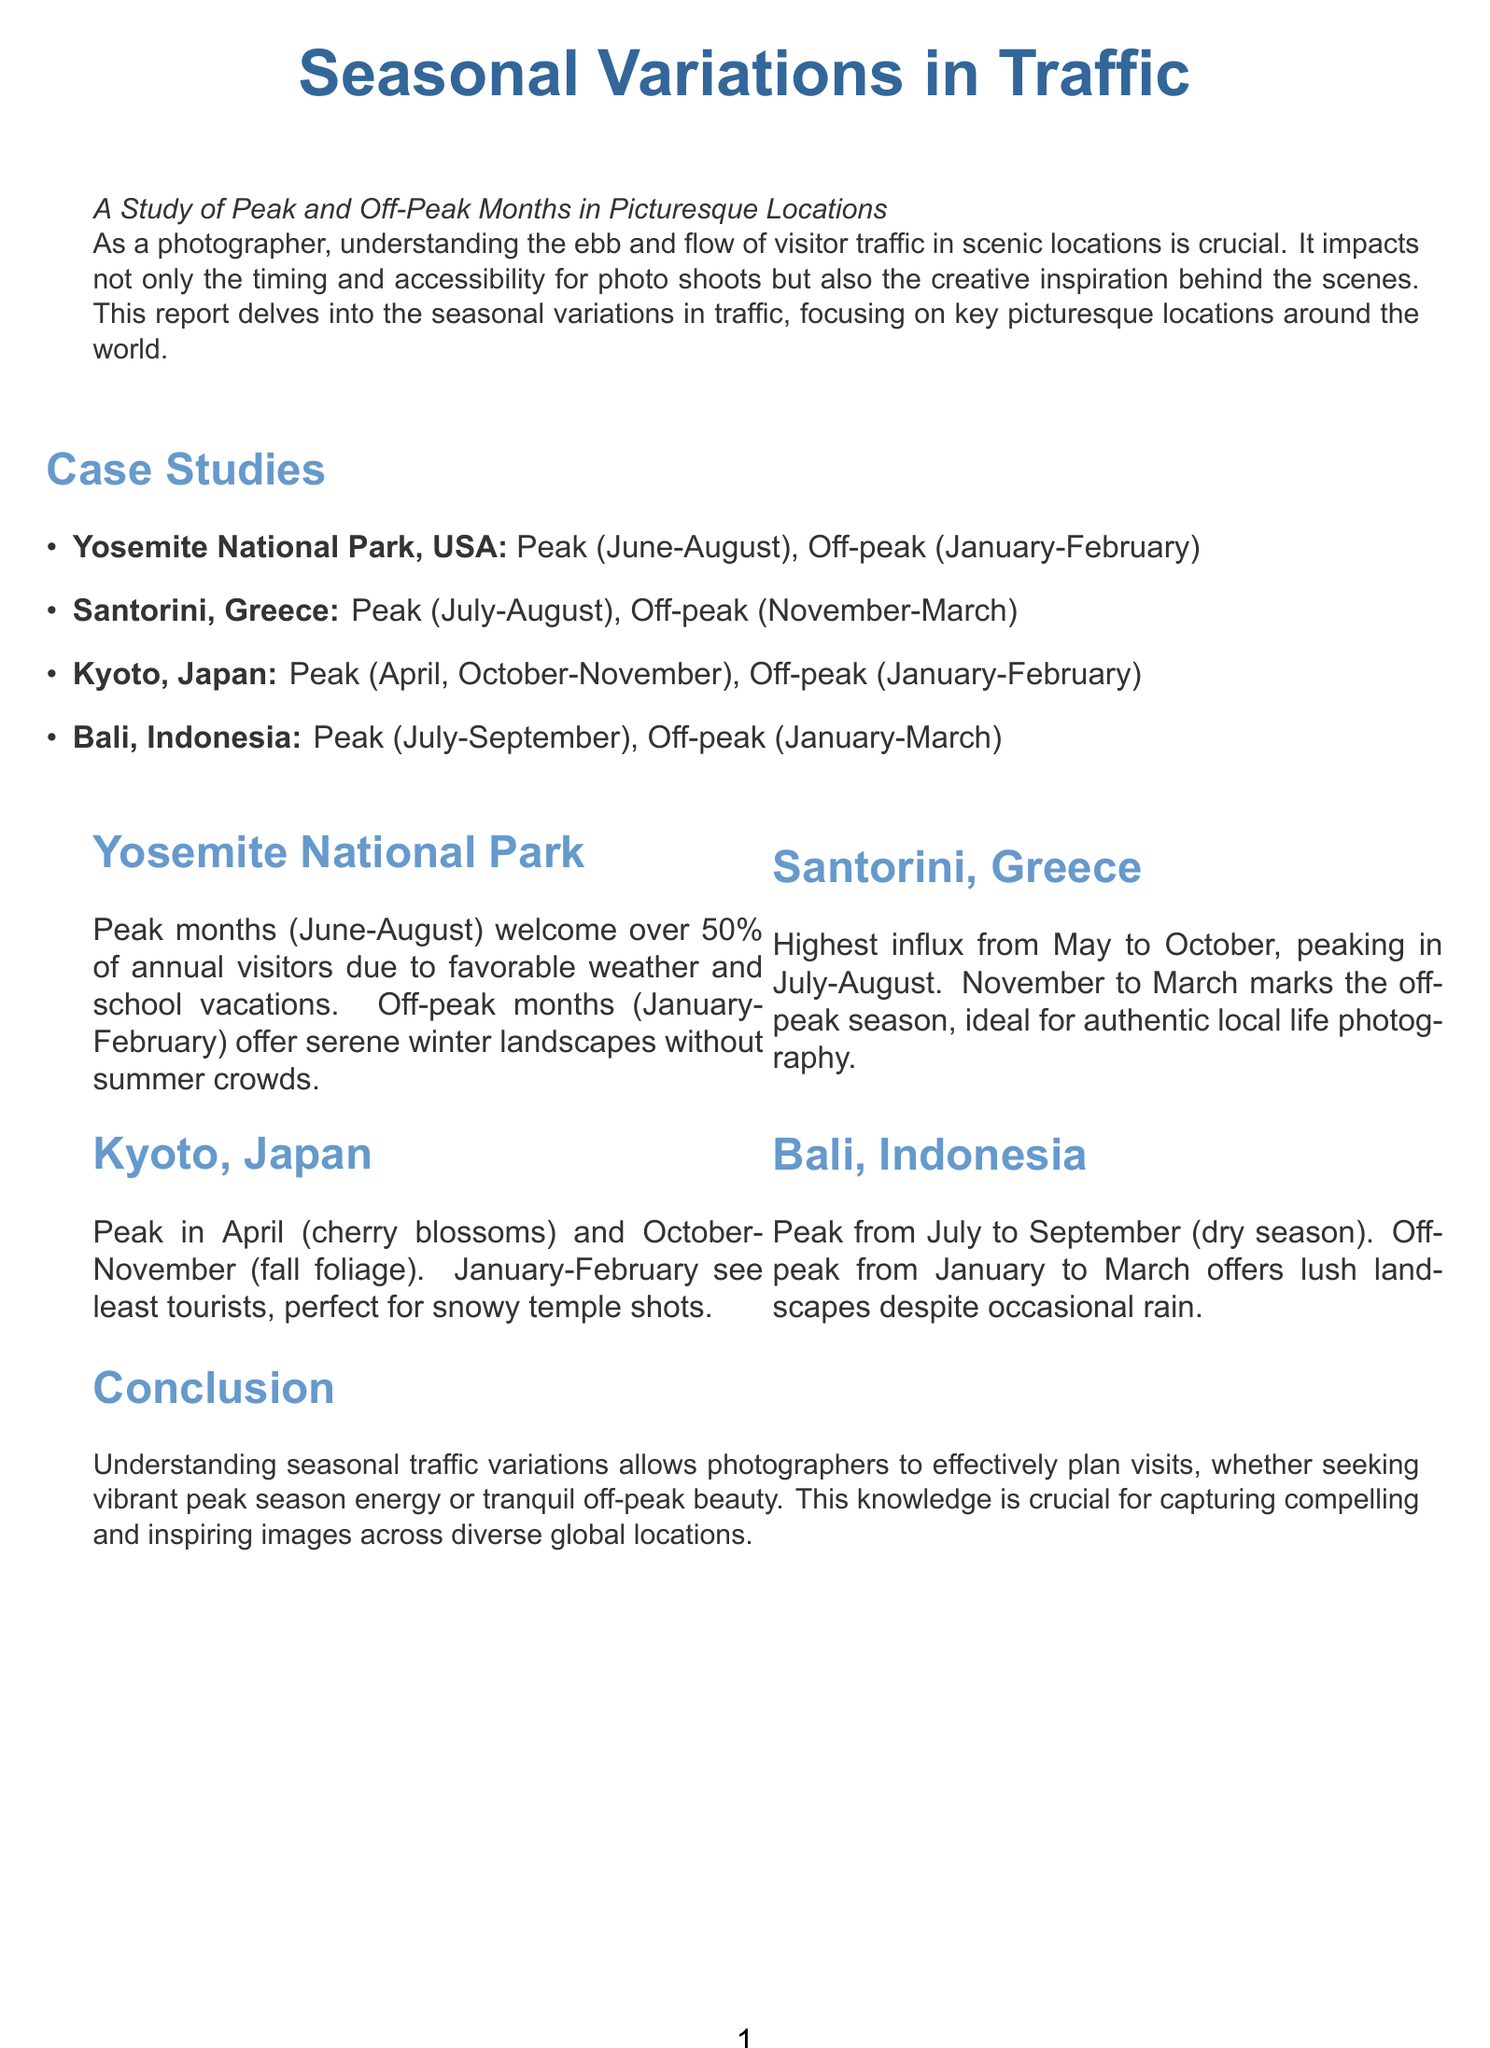What are the peak months for Yosemite National Park? The peak months are identified as June to August, based on the data presented in the case studies section of the report.
Answer: June-August What is the off-peak season for Santorini, Greece? The off-peak season for Santorini is specified as November to March, as noted in the case studies section.
Answer: November-March During which months does Kyoto, Japan, see the least tourists? The report indicates that the least tourists visit Kyoto during January and February.
Answer: January-February What is the peak season for Bali, Indonesia? The peak season for Bali is categorized as July to September in the case studies.
Answer: July-September Which month is highlighted for cherry blossoms in Kyoto? The report emphasizes April as the month for cherry blossoms in Kyoto, according to the case studies.
Answer: April Why is the off-peak season significant for photographers in Santorini? The report mentions that the off-peak season is ideal for capturing authentic local life photography, providing insights into its significance for photographers.
Answer: Authentic local life photography What percentage of annual visitors does Yosemite receive in peak months? The report states that over 50% of annual visitors come during peak months.
Answer: Over 50% What does off-peak season offer in terms of landscapes for Yosemite? The off-peak months provide serene winter landscapes, according to the description in the case studies.
Answer: Serene winter landscapes What is the conclusion drawn in this report? The conclusion emphasizes the importance of understanding seasonal traffic variations for effective planning and capturing compelling images.
Answer: Effective planning and capturing compelling images 